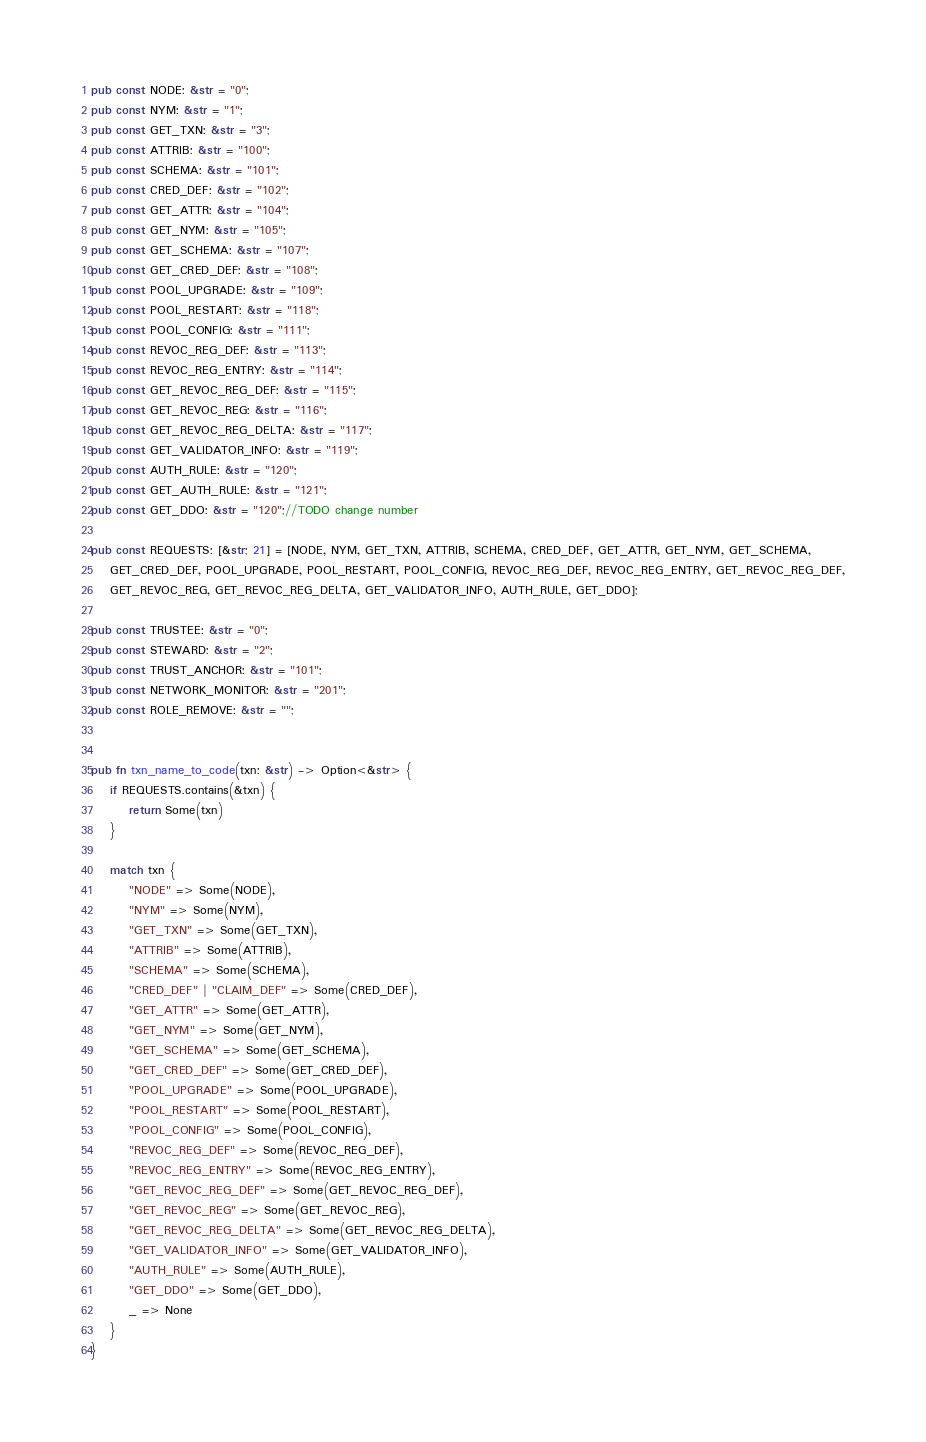<code> <loc_0><loc_0><loc_500><loc_500><_Rust_>pub const NODE: &str = "0";
pub const NYM: &str = "1";
pub const GET_TXN: &str = "3";
pub const ATTRIB: &str = "100";
pub const SCHEMA: &str = "101";
pub const CRED_DEF: &str = "102";
pub const GET_ATTR: &str = "104";
pub const GET_NYM: &str = "105";
pub const GET_SCHEMA: &str = "107";
pub const GET_CRED_DEF: &str = "108";
pub const POOL_UPGRADE: &str = "109";
pub const POOL_RESTART: &str = "118";
pub const POOL_CONFIG: &str = "111";
pub const REVOC_REG_DEF: &str = "113";
pub const REVOC_REG_ENTRY: &str = "114";
pub const GET_REVOC_REG_DEF: &str = "115";
pub const GET_REVOC_REG: &str = "116";
pub const GET_REVOC_REG_DELTA: &str = "117";
pub const GET_VALIDATOR_INFO: &str = "119";
pub const AUTH_RULE: &str = "120";
pub const GET_AUTH_RULE: &str = "121";
pub const GET_DDO: &str = "120";//TODO change number

pub const REQUESTS: [&str; 21] = [NODE, NYM, GET_TXN, ATTRIB, SCHEMA, CRED_DEF, GET_ATTR, GET_NYM, GET_SCHEMA,
    GET_CRED_DEF, POOL_UPGRADE, POOL_RESTART, POOL_CONFIG, REVOC_REG_DEF, REVOC_REG_ENTRY, GET_REVOC_REG_DEF,
    GET_REVOC_REG, GET_REVOC_REG_DELTA, GET_VALIDATOR_INFO, AUTH_RULE, GET_DDO];

pub const TRUSTEE: &str = "0";
pub const STEWARD: &str = "2";
pub const TRUST_ANCHOR: &str = "101";
pub const NETWORK_MONITOR: &str = "201";
pub const ROLE_REMOVE: &str = "";


pub fn txn_name_to_code(txn: &str) -> Option<&str> {
    if REQUESTS.contains(&txn) {
        return Some(txn)
    }

    match txn {
        "NODE" => Some(NODE),
        "NYM" => Some(NYM),
        "GET_TXN" => Some(GET_TXN),
        "ATTRIB" => Some(ATTRIB),
        "SCHEMA" => Some(SCHEMA),
        "CRED_DEF" | "CLAIM_DEF" => Some(CRED_DEF),
        "GET_ATTR" => Some(GET_ATTR),
        "GET_NYM" => Some(GET_NYM),
        "GET_SCHEMA" => Some(GET_SCHEMA),
        "GET_CRED_DEF" => Some(GET_CRED_DEF),
        "POOL_UPGRADE" => Some(POOL_UPGRADE),
        "POOL_RESTART" => Some(POOL_RESTART),
        "POOL_CONFIG" => Some(POOL_CONFIG),
        "REVOC_REG_DEF" => Some(REVOC_REG_DEF),
        "REVOC_REG_ENTRY" => Some(REVOC_REG_ENTRY),
        "GET_REVOC_REG_DEF" => Some(GET_REVOC_REG_DEF),
        "GET_REVOC_REG" => Some(GET_REVOC_REG),
        "GET_REVOC_REG_DELTA" => Some(GET_REVOC_REG_DELTA),
        "GET_VALIDATOR_INFO" => Some(GET_VALIDATOR_INFO),
        "AUTH_RULE" => Some(AUTH_RULE),
        "GET_DDO" => Some(GET_DDO),
        _ => None
    }
}</code> 